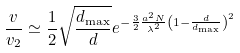<formula> <loc_0><loc_0><loc_500><loc_500>\frac { v } { v _ { 2 } } \simeq \frac { 1 } { 2 } \sqrt { \frac { d _ { \max } } { d } } e ^ { - \frac { 3 } { 2 } \frac { a ^ { 2 } N } { \lambda ^ { 2 } } \left ( 1 - \frac { d } { d _ { \max } } \right ) ^ { 2 } }</formula> 